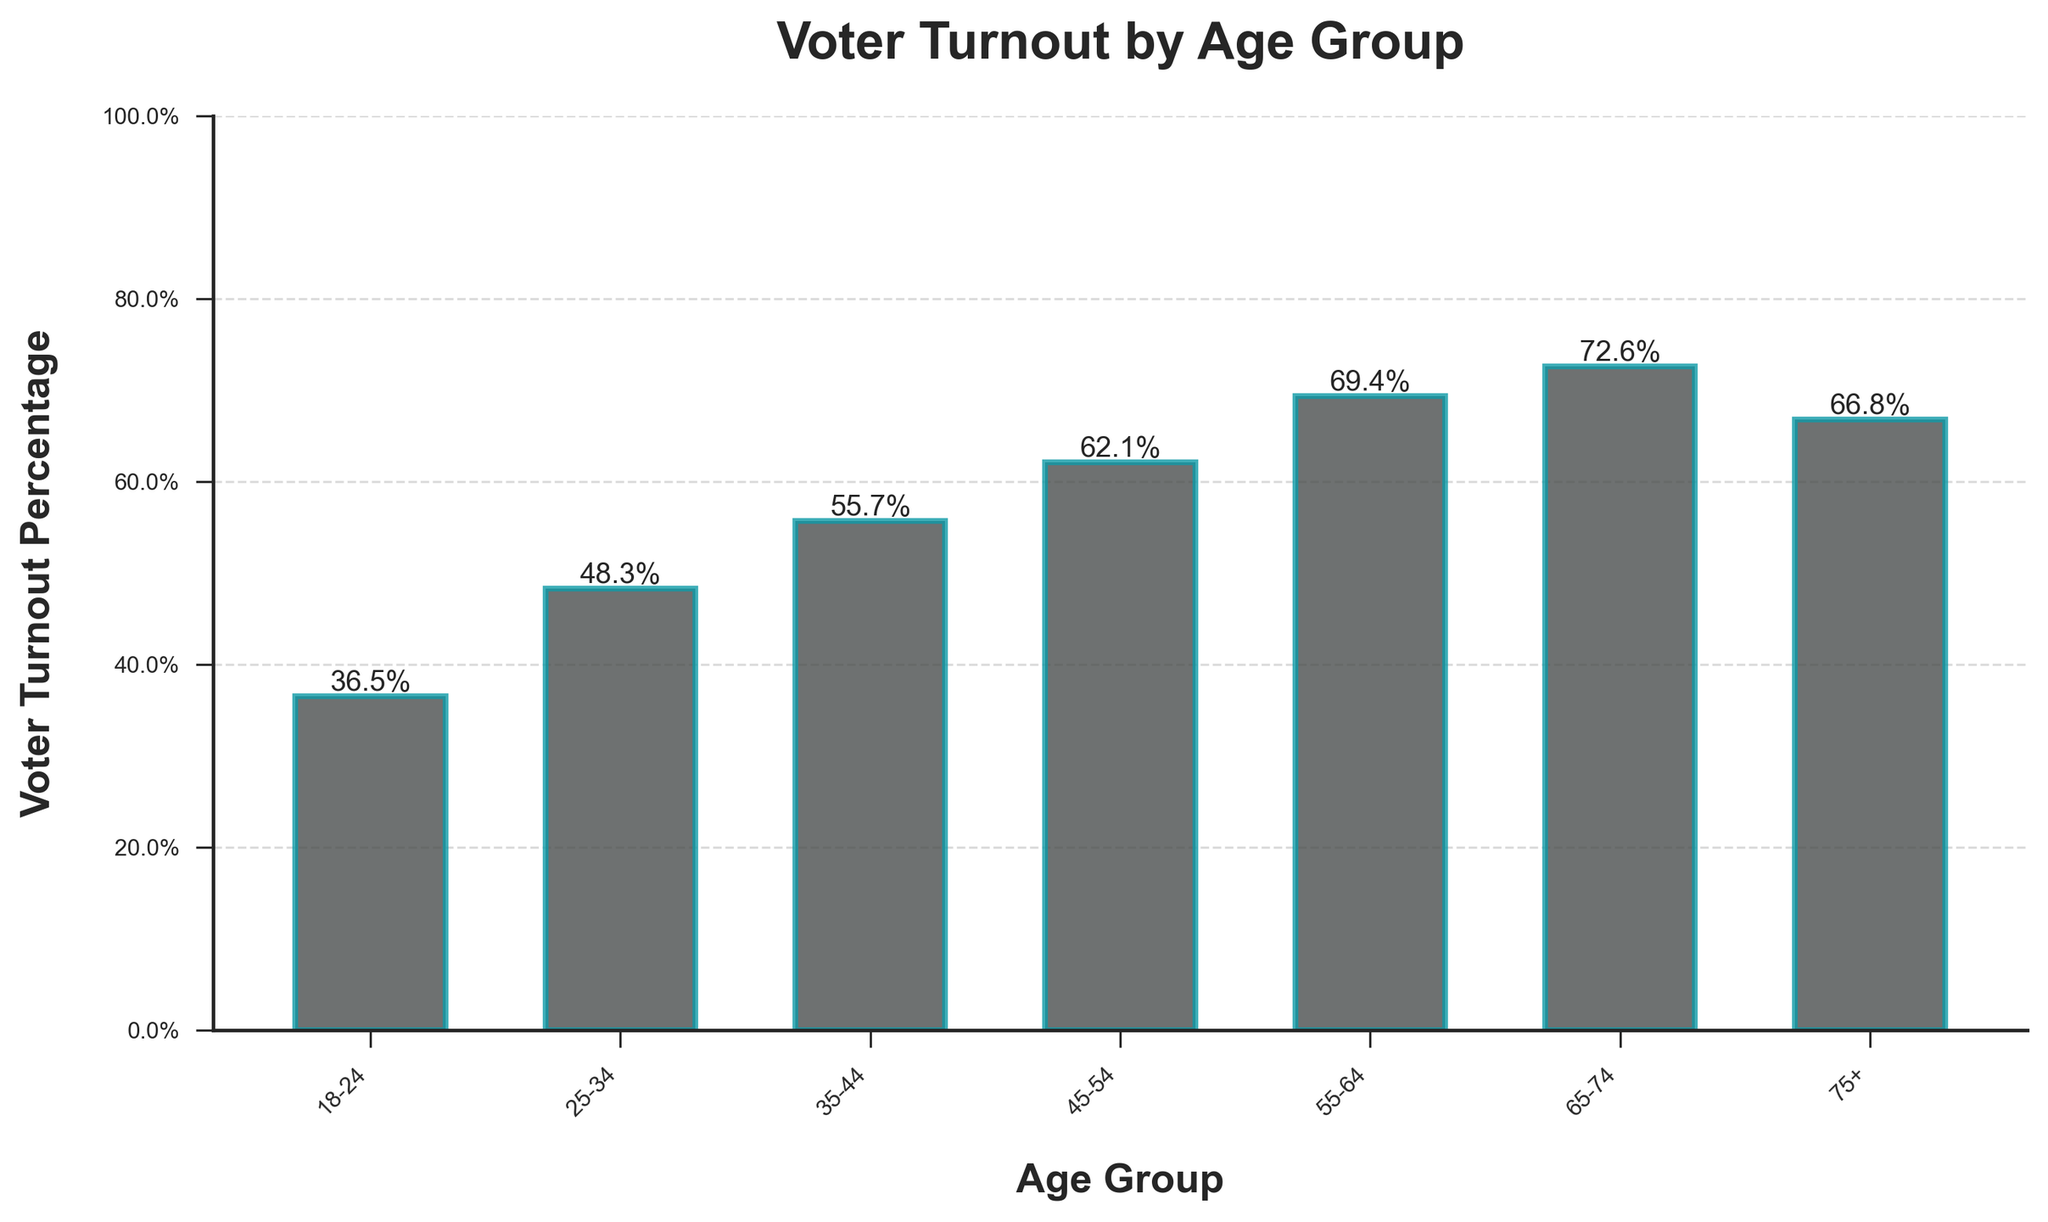What's the voter turnout percentage for the age group 55-64? Locate the bar corresponding to the 55-64 age group and read the height of the bar. The figure at the top of the bar will indicate the percentage.
Answer: 69.4% For age groups 18-24 and 75+, which has a higher voter turnout percentage and by how much? Compare the heights of the bars for age groups 18-24 and 75+, noting the percentages at the top of each bar. Subtract the smaller percentage from the larger one.
Answer: Age group 75+ by 30.3% Among the age groups, which one has the lowest voter turnout percentage? Identify the shortest bar in the chart, as the shortest bar represents the lowest voter turnout percentage. Look at the label and percentage on that bar.
Answer: 18-24 What is the average voter turnout percentage across all age groups shown? Add the voter turnout percentages for all age groups, then divide the sum by the total number of age groups. Calculation: (36.5 + 48.3 + 55.7 + 62.1 + 69.4 + 72.6 + 66.8) / 7.
Answer: 58.8% What is the difference in voter turnout percentage between the age groups 25-34 and 65-74? Look at the bars for age groups 25-34 and 65-74. Subtract the percentage of 25-34 from the percentage of 65-74.
Answer: 24.3% Between which two consecutive age groups is there the largest increase in voter turnout percentage? Compare the difference in voter turnout between each pair of consecutive age groups. Identify the largest difference.
Answer: 18-24 to 25-34 How does the turnout percentage for the 45-54 age group compare visually in height to the 55-64 age group? Observe the heights of the bars corresponding to the 45-54 and 55-64 age groups. Note which bar is taller and by how much.
Answer: 55-64 is higher What is the median voter turnout percentage among the age groups? Arrange the voter turnout percentages across all age groups in ascending order: 36.5, 48.3, 55.7, 62.1, 66.8, 69.4, 72.6. The middle value in this ordered list is the median.
Answer: 62.1% If I combine the voter turnout percentages for the age groups 35-44, 45-54, and 55-64, what total percentage do I get? Sum the voter turnout percentages for the age groups 35-44, 45-54, and 55-64. Calculation: 55.7 + 62.1 + 69.4.
Answer: 187.2% Which age group has a voter turnout percentage closest to the overall average of all age groups? Calculate the average voter turnout percentage. Identify the age group's percentage that is closest to this average. The overall average is 58.8%.
Answer: 55-64 